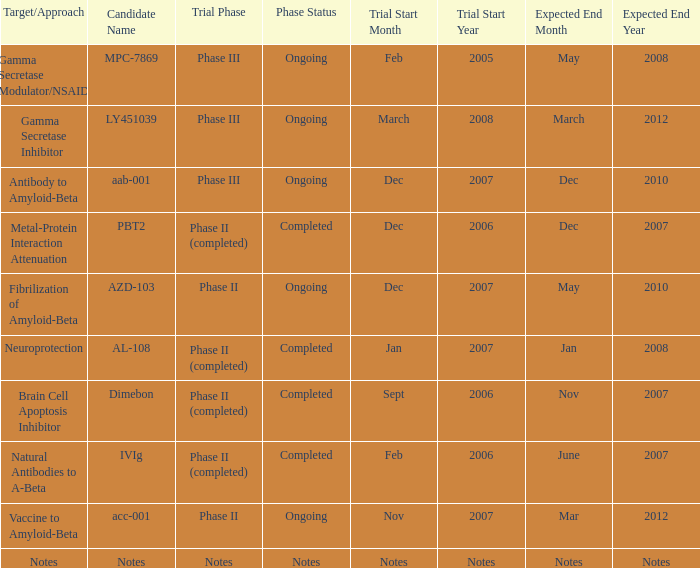What is Trial Phase, when Expected End Date is June 2007? Phase II (completed). 